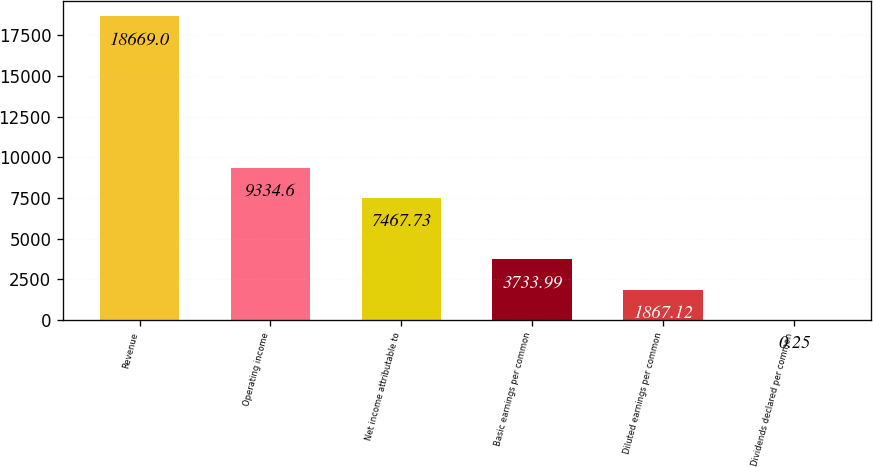Convert chart. <chart><loc_0><loc_0><loc_500><loc_500><bar_chart><fcel>Revenue<fcel>Operating income<fcel>Net income attributable to<fcel>Basic earnings per common<fcel>Diluted earnings per common<fcel>Dividends declared per common<nl><fcel>18669<fcel>9334.6<fcel>7467.73<fcel>3733.99<fcel>1867.12<fcel>0.25<nl></chart> 